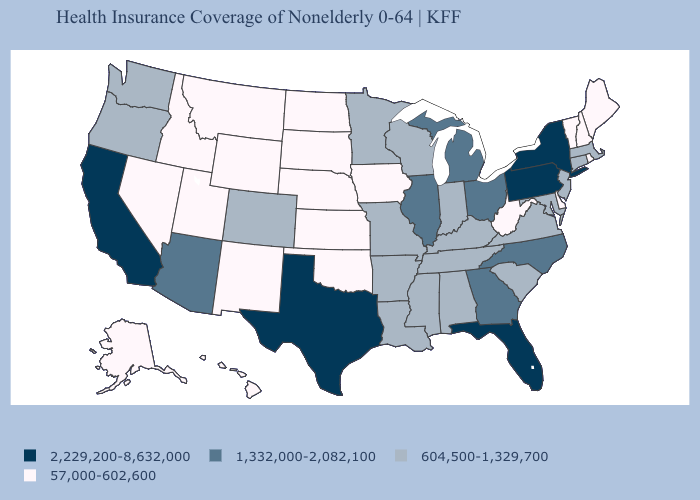Name the states that have a value in the range 2,229,200-8,632,000?
Quick response, please. California, Florida, New York, Pennsylvania, Texas. Does Arizona have the same value as Utah?
Write a very short answer. No. What is the value of Hawaii?
Keep it brief. 57,000-602,600. Name the states that have a value in the range 57,000-602,600?
Short answer required. Alaska, Delaware, Hawaii, Idaho, Iowa, Kansas, Maine, Montana, Nebraska, Nevada, New Hampshire, New Mexico, North Dakota, Oklahoma, Rhode Island, South Dakota, Utah, Vermont, West Virginia, Wyoming. Does Georgia have the highest value in the USA?
Answer briefly. No. Does West Virginia have the lowest value in the South?
Short answer required. Yes. Name the states that have a value in the range 57,000-602,600?
Write a very short answer. Alaska, Delaware, Hawaii, Idaho, Iowa, Kansas, Maine, Montana, Nebraska, Nevada, New Hampshire, New Mexico, North Dakota, Oklahoma, Rhode Island, South Dakota, Utah, Vermont, West Virginia, Wyoming. What is the value of Missouri?
Short answer required. 604,500-1,329,700. What is the lowest value in the USA?
Quick response, please. 57,000-602,600. Does South Dakota have the lowest value in the USA?
Quick response, please. Yes. What is the highest value in the USA?
Concise answer only. 2,229,200-8,632,000. Name the states that have a value in the range 57,000-602,600?
Concise answer only. Alaska, Delaware, Hawaii, Idaho, Iowa, Kansas, Maine, Montana, Nebraska, Nevada, New Hampshire, New Mexico, North Dakota, Oklahoma, Rhode Island, South Dakota, Utah, Vermont, West Virginia, Wyoming. What is the lowest value in the USA?
Answer briefly. 57,000-602,600. Does Oklahoma have the lowest value in the South?
Write a very short answer. Yes. 